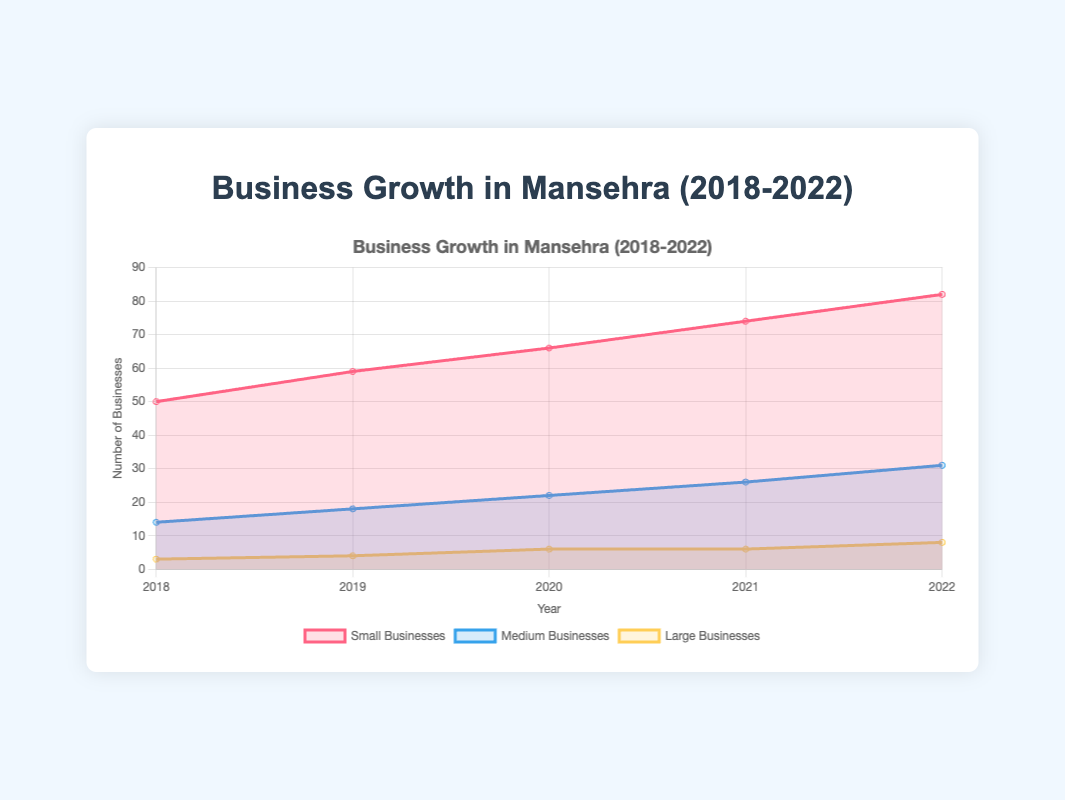What is the trend for small businesses from 2018 to 2022? Observe the line representing small businesses. It starts at 50 in 2018 and progressively increases each year, reaching 82 in 2022.
Answer: Increasing How many types of large businesses were there in 2019? In 2019, the number of large businesses is the sum of shopping malls (1), hospitals (1), universities (1), and large hotels (1).
Answer: 4 Between which two years did medium businesses grow the most? Compare the growth between consecutive years by observing the medium businesses line. The largest increase occurs from 2021 (26) to 2022 (31).
Answer: 2021-2022 Which year had the highest number of total small businesses? To find the highest total, sum the values for small businesses each year. 2022 has the highest total of 82 small businesses (25+30+18+9).
Answer: 2022 By how much did large businesses increase from 2018 to 2022? Calculate the difference in large businesses from 2018 (3) to 2022 (8). 8 - 3 = 5.
Answer: 5 In which year did the number of transport services show the smallest increase compared to the previous year? Observe transport services:
2018-2019: 5 to 6 → +1,
2019-2020: 6 to 7 → +1,
2020-2021: 7 to 8 → +1,
2021-2022: 8 to 9 → +1. 
They increased by the same amount every year.
Answer: All years equally How many more small businesses were there than medium businesses in 2020? Sum the small businesses (20+25+14+7) = 66 and medium businesses (5+6+7+4) = 22. The difference is 66 - 22 = 44.
Answer: 44 Which business type saw the most growth in large businesses from 2018 to 2022? Shopping malls increased from 1 to 2, hospitals remained the same (1), universities grew from 0 to 2, and large hotels increased from 1 to 3. Large hotels had the most significant growth (3-1=2).
Answer: Large hotels Compare the number of professional services and education centers in 2022. Which is higher? In 2022, professional services are at 10, and education centers are at 6. Professional services are higher.
Answer: Professional services What is the total number of businesses in 2021? Add small (22+28+16+8) = 74, medium (6+7+8+5) = 26, and large businesses (2+1+1+2) = 6. The total is 74 + 26 + 6 = 106.
Answer: 106 